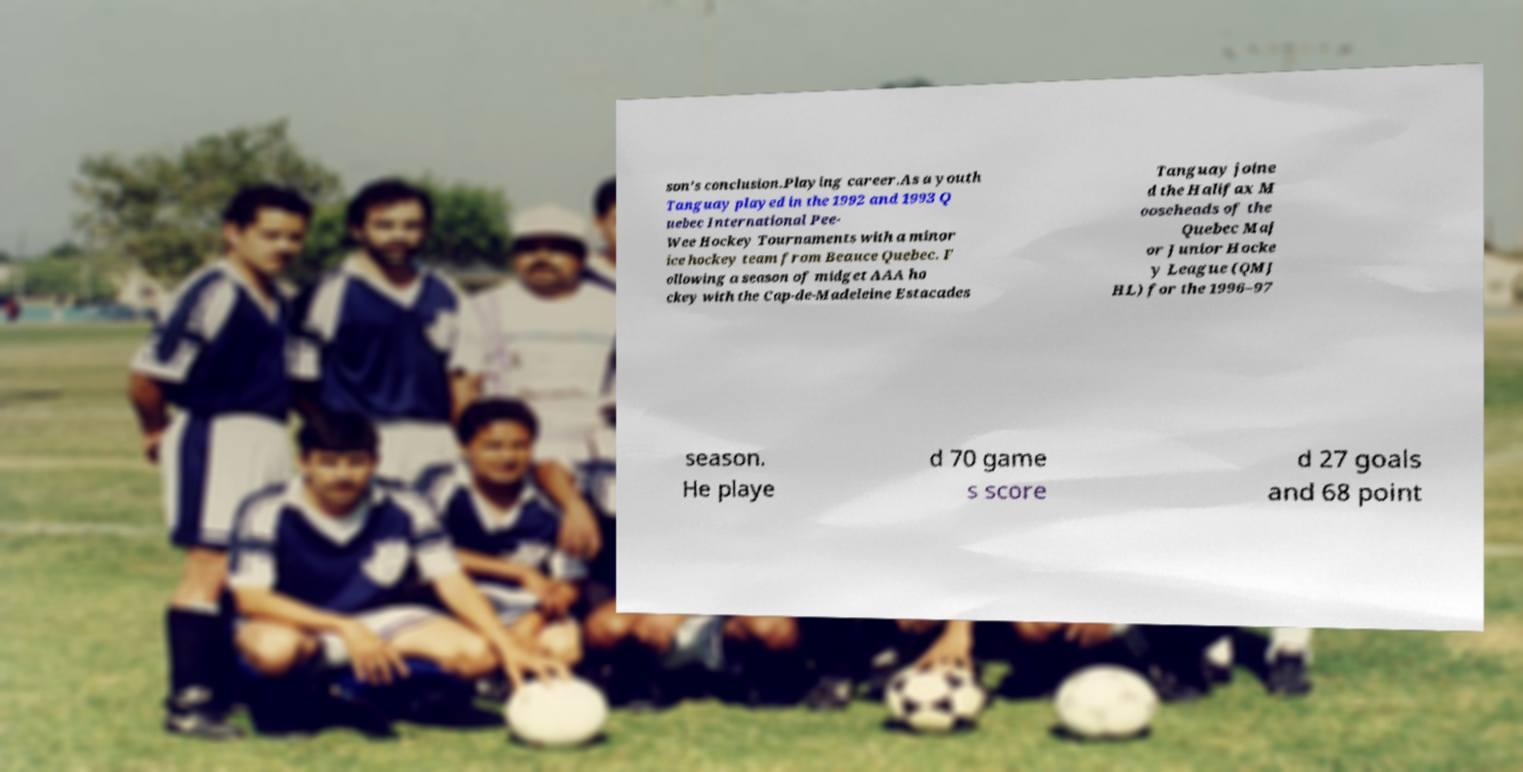What messages or text are displayed in this image? I need them in a readable, typed format. son's conclusion.Playing career.As a youth Tanguay played in the 1992 and 1993 Q uebec International Pee- Wee Hockey Tournaments with a minor ice hockey team from Beauce Quebec. F ollowing a season of midget AAA ho ckey with the Cap-de-Madeleine Estacades Tanguay joine d the Halifax M ooseheads of the Quebec Maj or Junior Hocke y League (QMJ HL) for the 1996–97 season. He playe d 70 game s score d 27 goals and 68 point 